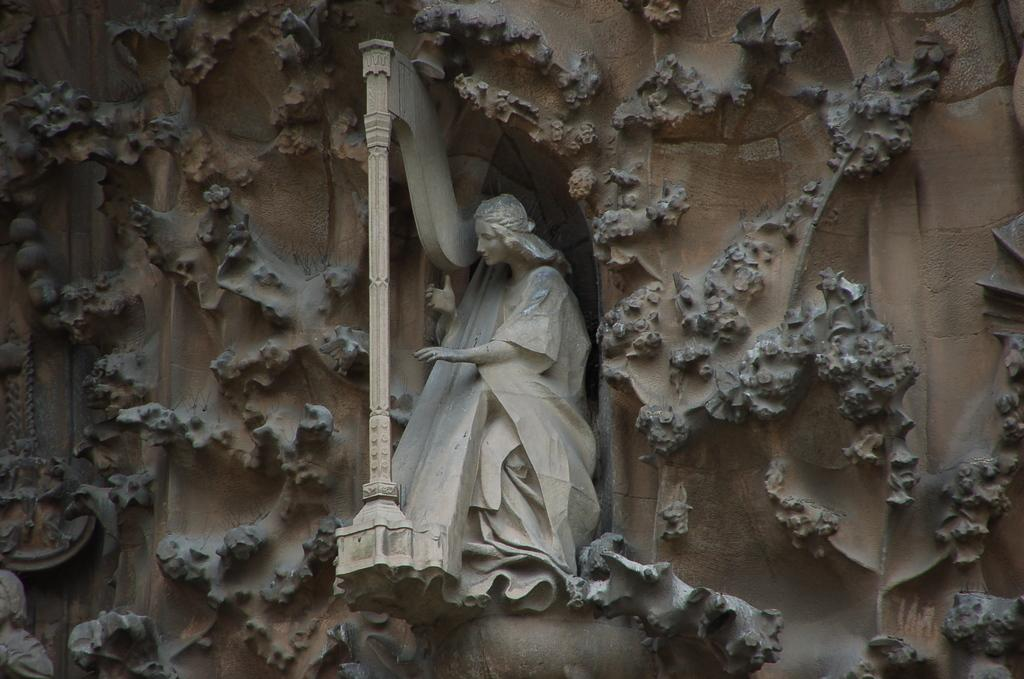What is the main subject of the image? There is a statue in the image. Where is the statue located? The statue is on the wall. What type of pencil can be seen in the statue's hand in the image? There is no pencil present in the image, and the statue does not have a hand. 